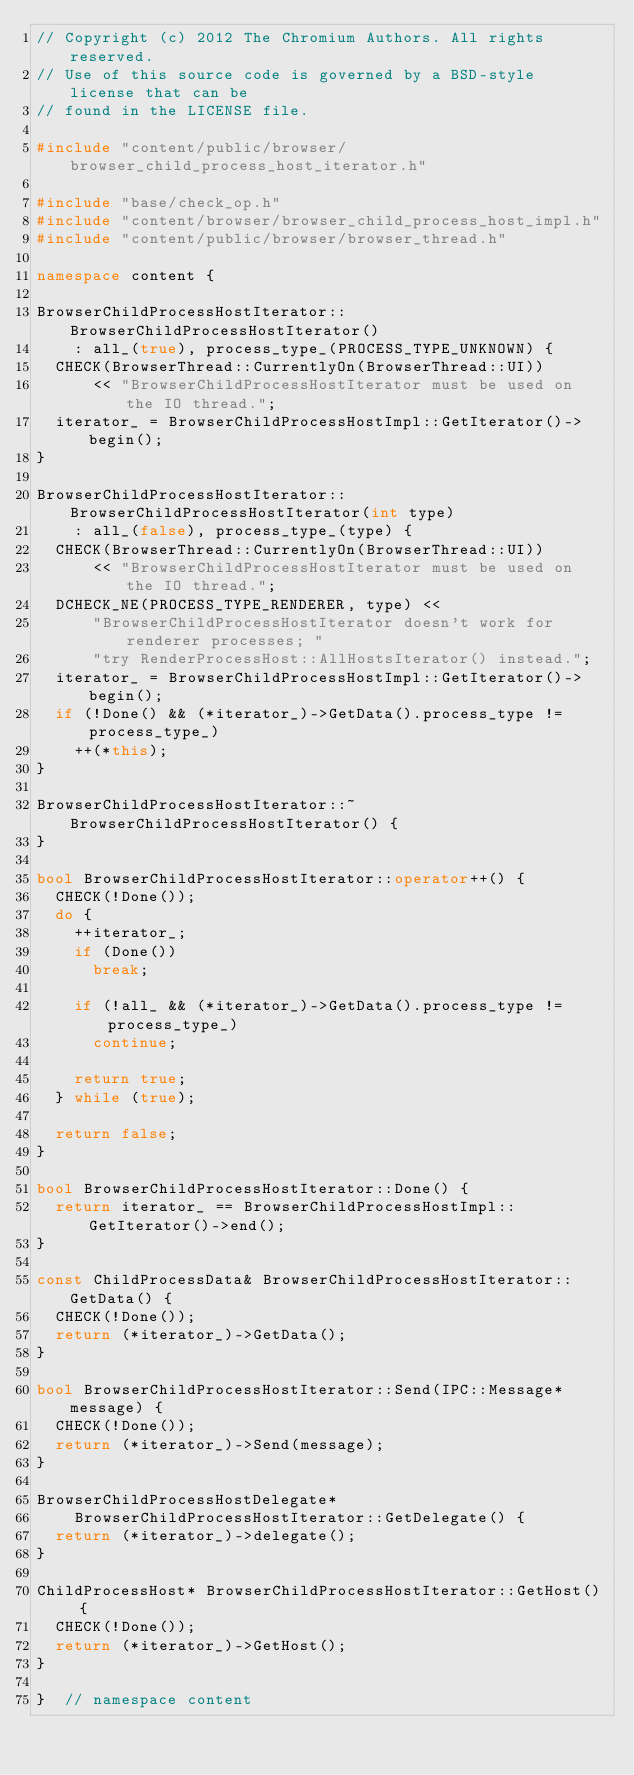<code> <loc_0><loc_0><loc_500><loc_500><_C++_>// Copyright (c) 2012 The Chromium Authors. All rights reserved.
// Use of this source code is governed by a BSD-style license that can be
// found in the LICENSE file.

#include "content/public/browser/browser_child_process_host_iterator.h"

#include "base/check_op.h"
#include "content/browser/browser_child_process_host_impl.h"
#include "content/public/browser/browser_thread.h"

namespace content {

BrowserChildProcessHostIterator::BrowserChildProcessHostIterator()
    : all_(true), process_type_(PROCESS_TYPE_UNKNOWN) {
  CHECK(BrowserThread::CurrentlyOn(BrowserThread::UI))
      << "BrowserChildProcessHostIterator must be used on the IO thread.";
  iterator_ = BrowserChildProcessHostImpl::GetIterator()->begin();
}

BrowserChildProcessHostIterator::BrowserChildProcessHostIterator(int type)
    : all_(false), process_type_(type) {
  CHECK(BrowserThread::CurrentlyOn(BrowserThread::UI))
      << "BrowserChildProcessHostIterator must be used on the IO thread.";
  DCHECK_NE(PROCESS_TYPE_RENDERER, type) <<
      "BrowserChildProcessHostIterator doesn't work for renderer processes; "
      "try RenderProcessHost::AllHostsIterator() instead.";
  iterator_ = BrowserChildProcessHostImpl::GetIterator()->begin();
  if (!Done() && (*iterator_)->GetData().process_type != process_type_)
    ++(*this);
}

BrowserChildProcessHostIterator::~BrowserChildProcessHostIterator() {
}

bool BrowserChildProcessHostIterator::operator++() {
  CHECK(!Done());
  do {
    ++iterator_;
    if (Done())
      break;

    if (!all_ && (*iterator_)->GetData().process_type != process_type_)
      continue;

    return true;
  } while (true);

  return false;
}

bool BrowserChildProcessHostIterator::Done() {
  return iterator_ == BrowserChildProcessHostImpl::GetIterator()->end();
}

const ChildProcessData& BrowserChildProcessHostIterator::GetData() {
  CHECK(!Done());
  return (*iterator_)->GetData();
}

bool BrowserChildProcessHostIterator::Send(IPC::Message* message) {
  CHECK(!Done());
  return (*iterator_)->Send(message);
}

BrowserChildProcessHostDelegate*
    BrowserChildProcessHostIterator::GetDelegate() {
  return (*iterator_)->delegate();
}

ChildProcessHost* BrowserChildProcessHostIterator::GetHost() {
  CHECK(!Done());
  return (*iterator_)->GetHost();
}

}  // namespace content
</code> 